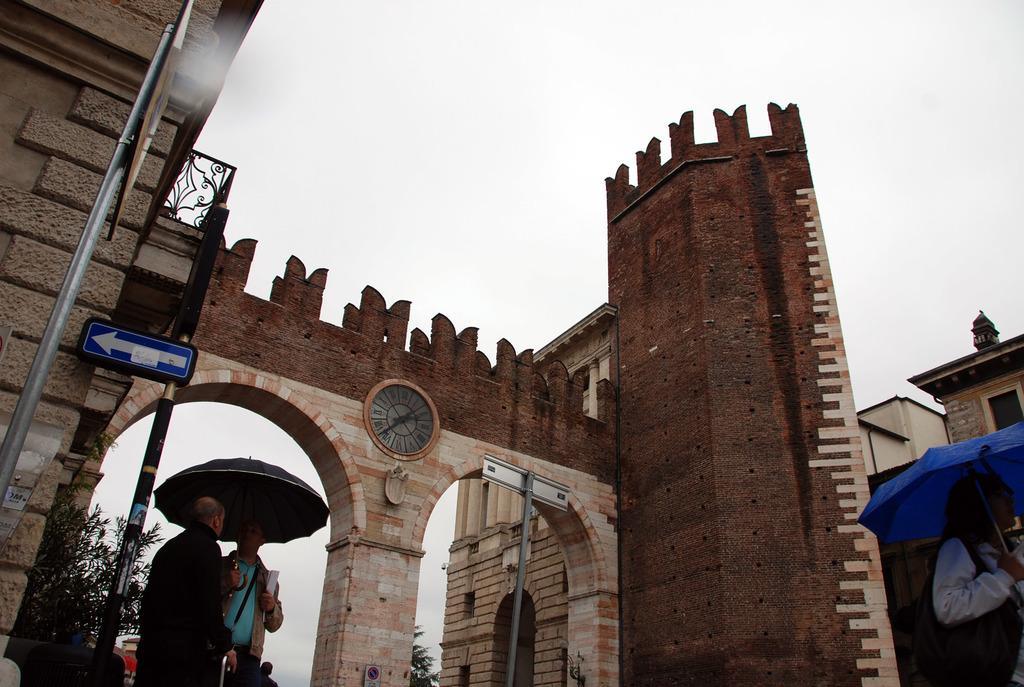Could you give a brief overview of what you see in this image? This is an outside view. At the bottom of the image I can see few people. One person is is holding a blue color umbrella and walking. On the left side two persons are standing and holding an umbrella in the hands and looking at each other. In the background, I can see the buildings. On the left side there is a pole to which a board is attached. In the background there are some trees. On the top of the image I can see the sky. 